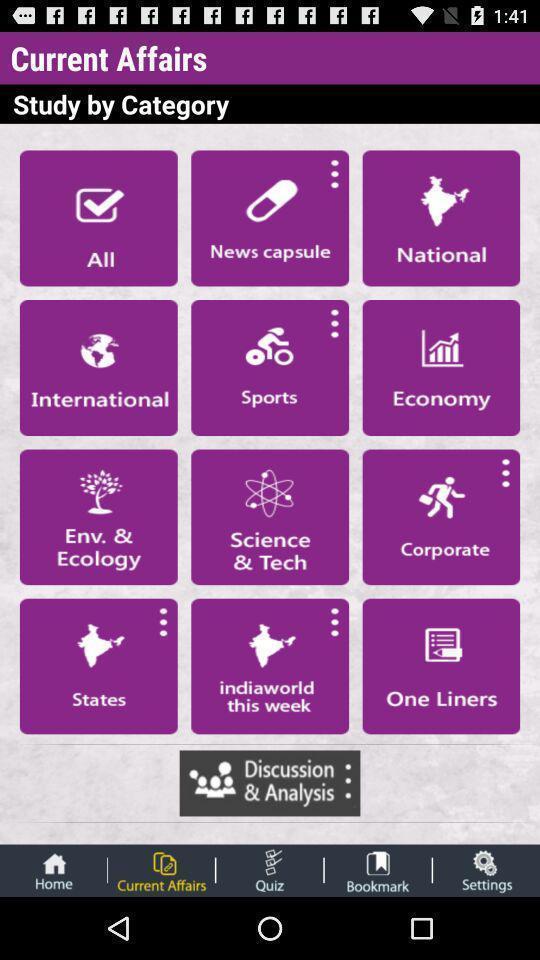Provide a detailed account of this screenshot. Screen display list of various categories in study app. 